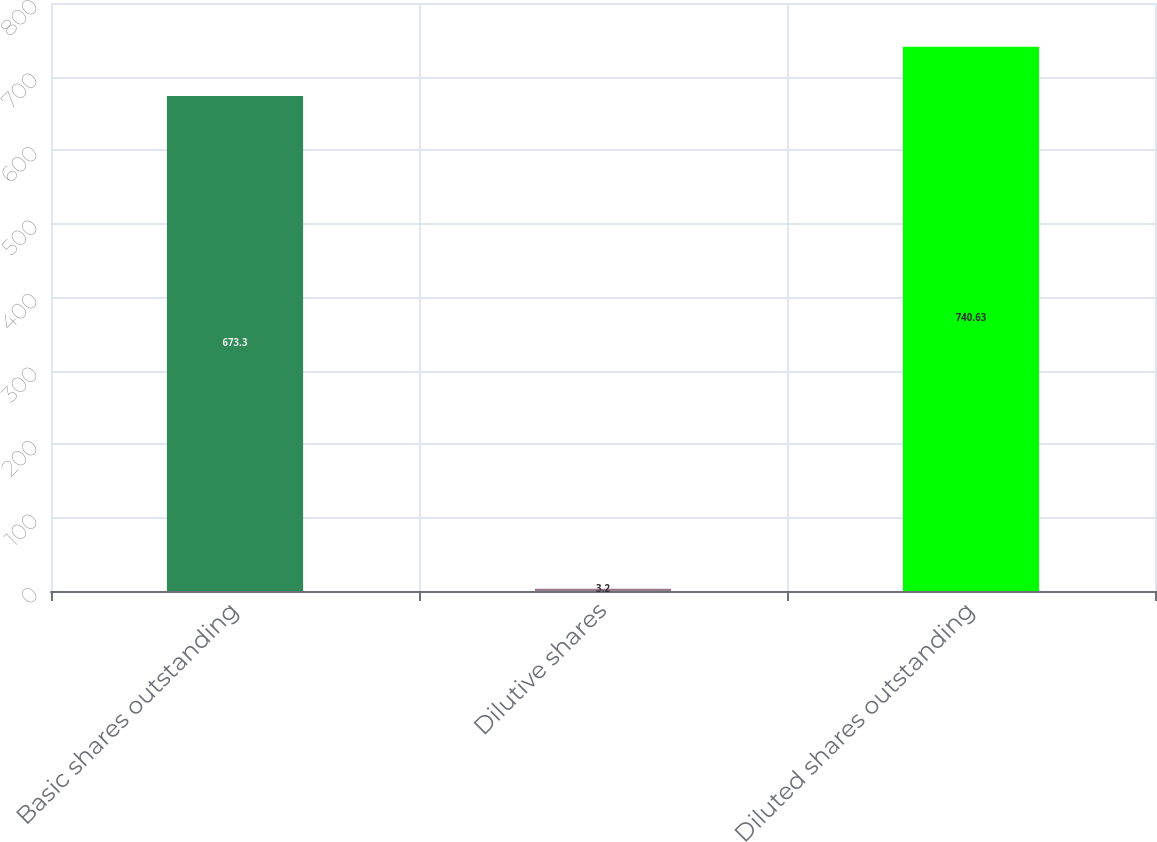<chart> <loc_0><loc_0><loc_500><loc_500><bar_chart><fcel>Basic shares outstanding<fcel>Dilutive shares<fcel>Diluted shares outstanding<nl><fcel>673.3<fcel>3.2<fcel>740.63<nl></chart> 